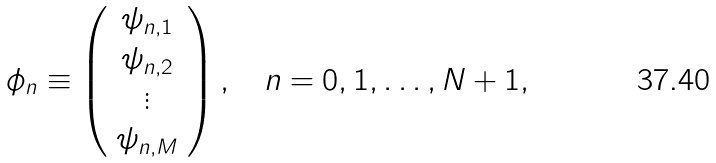Convert formula to latex. <formula><loc_0><loc_0><loc_500><loc_500>\phi _ { n } \equiv \left ( \begin{array} { c } \psi _ { n , 1 } \\ \psi _ { n , 2 } \\ \vdots \\ \psi _ { n , M } \end{array} \right ) , \quad n = 0 , 1 , \dots , N + 1 ,</formula> 